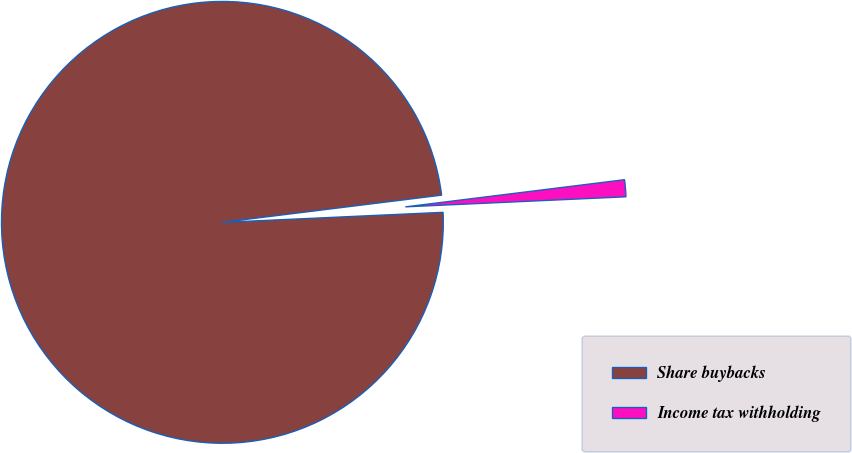Convert chart to OTSL. <chart><loc_0><loc_0><loc_500><loc_500><pie_chart><fcel>Share buybacks<fcel>Income tax withholding<nl><fcel>98.76%<fcel>1.24%<nl></chart> 